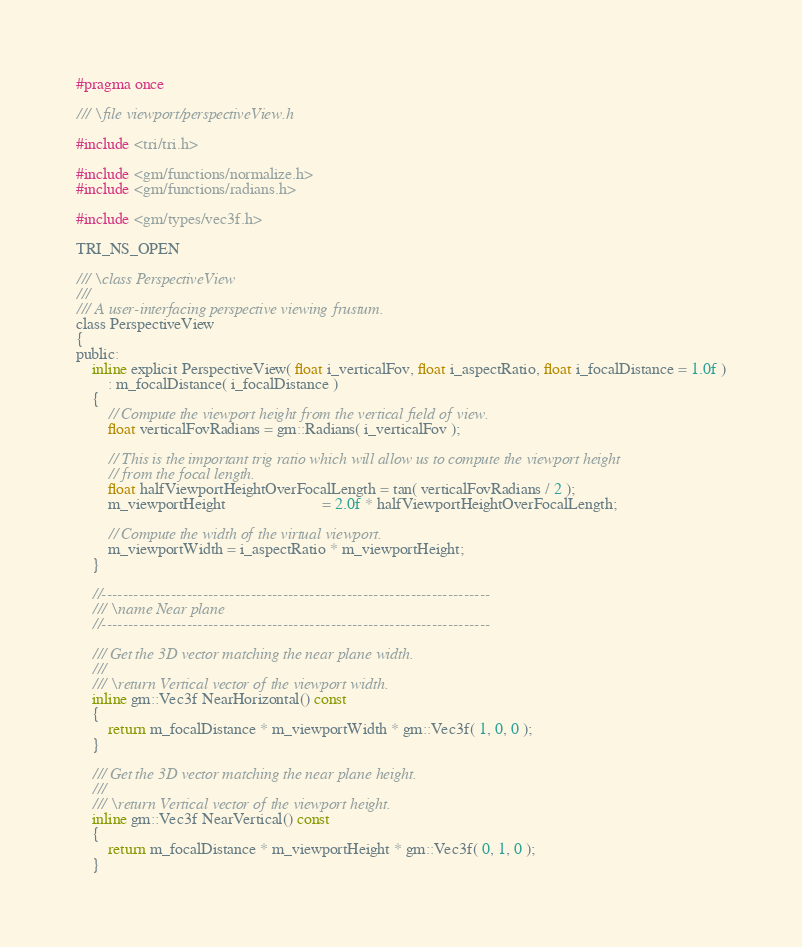Convert code to text. <code><loc_0><loc_0><loc_500><loc_500><_C_>#pragma once

/// \file viewport/perspectiveView.h

#include <tri/tri.h>

#include <gm/functions/normalize.h>
#include <gm/functions/radians.h>

#include <gm/types/vec3f.h>

TRI_NS_OPEN

/// \class PerspectiveView
///
/// A user-interfacing perspective viewing frustum.
class PerspectiveView
{
public:
    inline explicit PerspectiveView( float i_verticalFov, float i_aspectRatio, float i_focalDistance = 1.0f )
        : m_focalDistance( i_focalDistance )
    {
        // Compute the viewport height from the vertical field of view.
        float verticalFovRadians = gm::Radians( i_verticalFov );

        // This is the important trig ratio which will allow us to compute the viewport height
        // from the focal length.
        float halfViewportHeightOverFocalLength = tan( verticalFovRadians / 2 );
        m_viewportHeight                        = 2.0f * halfViewportHeightOverFocalLength;

        // Compute the width of the virtual viewport.
        m_viewportWidth = i_aspectRatio * m_viewportHeight;
    }

    //-------------------------------------------------------------------------
    /// \name Near plane
    //-------------------------------------------------------------------------

    /// Get the 3D vector matching the near plane width.
    ///
    /// \return Vertical vector of the viewport width.
    inline gm::Vec3f NearHorizontal() const
    {
        return m_focalDistance * m_viewportWidth * gm::Vec3f( 1, 0, 0 );
    }

    /// Get the 3D vector matching the near plane height.
    ///
    /// \return Vertical vector of the viewport height.
    inline gm::Vec3f NearVertical() const
    {
        return m_focalDistance * m_viewportHeight * gm::Vec3f( 0, 1, 0 );
    }
</code> 